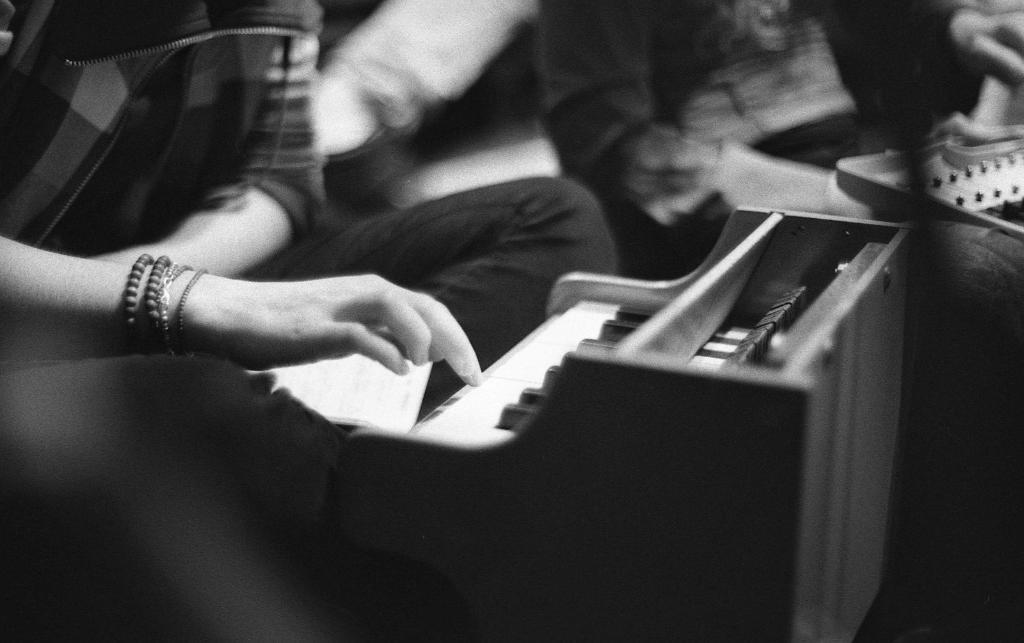Please provide a concise description of this image. In the picture I can see a person on the left side though face is not visible. The person is playing the piano. 